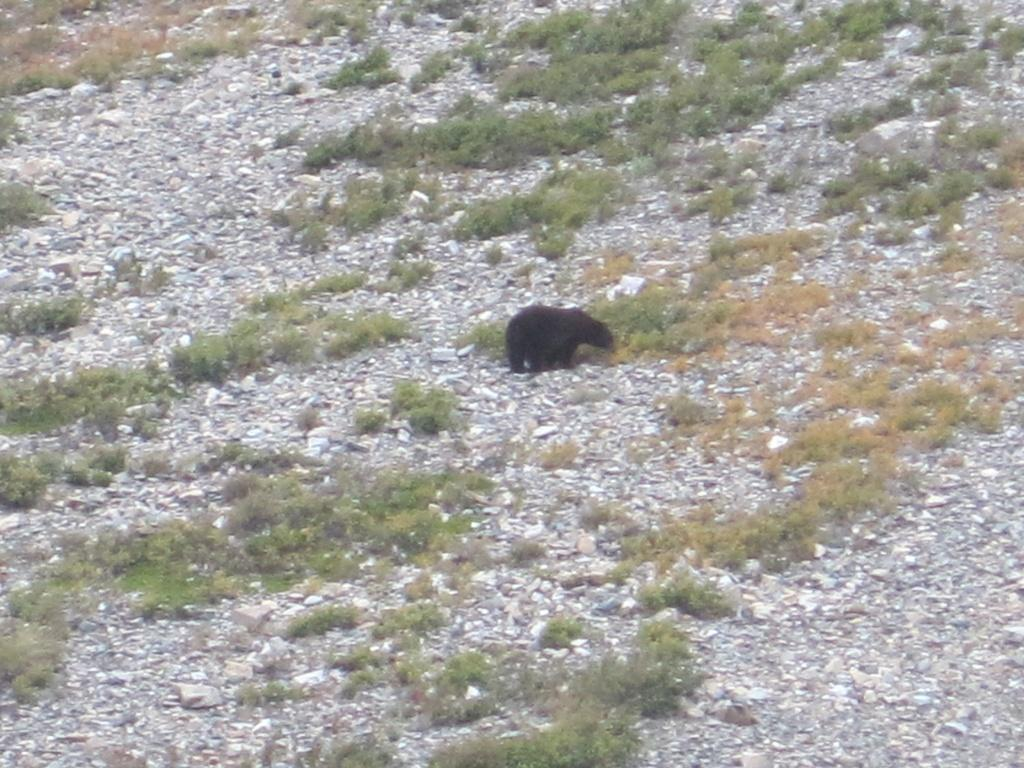What type of animal is in the image? There is a black color bear in the image. What other elements can be seen in the image besides the bear? There are small plants in the image. Where are the small plants located? The small plants are on the land. How many ants are crawling on the bear's shirt in the image? There are no ants or shirts present in the image; it features a black color bear and small plants. 